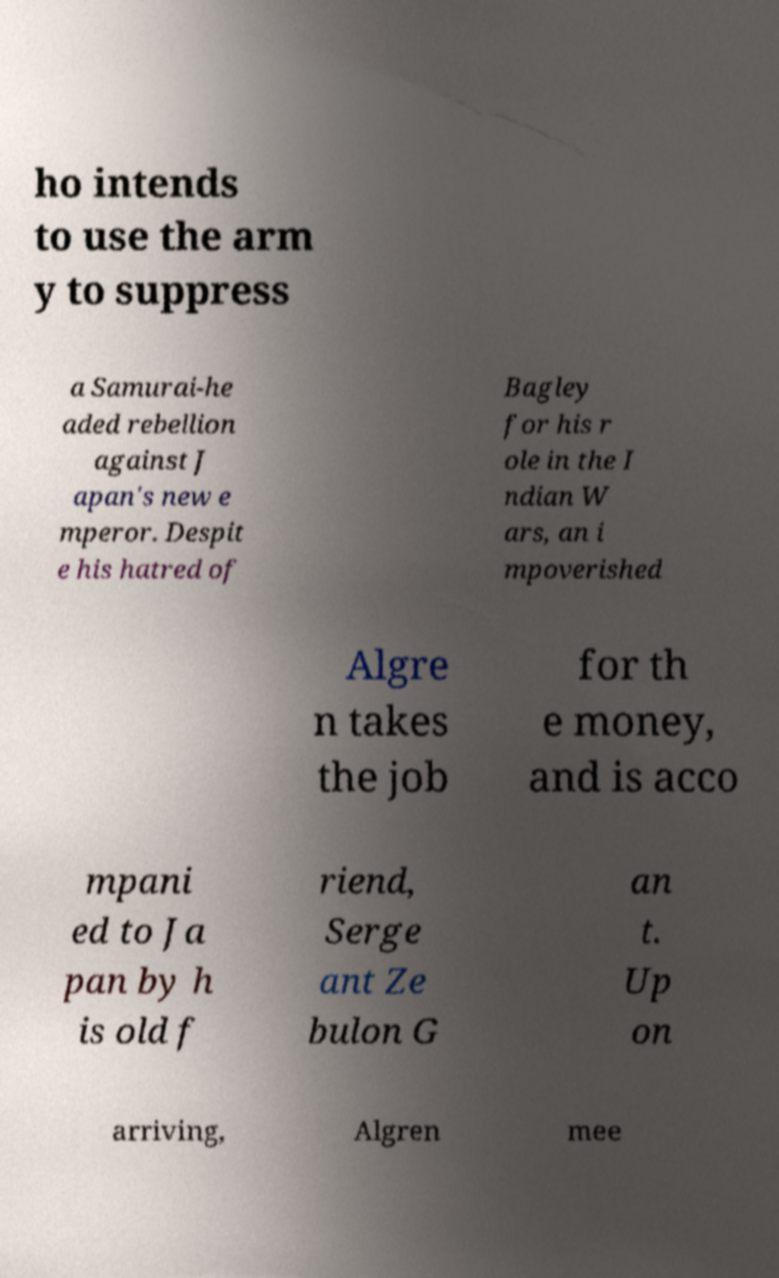There's text embedded in this image that I need extracted. Can you transcribe it verbatim? ho intends to use the arm y to suppress a Samurai-he aded rebellion against J apan's new e mperor. Despit e his hatred of Bagley for his r ole in the I ndian W ars, an i mpoverished Algre n takes the job for th e money, and is acco mpani ed to Ja pan by h is old f riend, Serge ant Ze bulon G an t. Up on arriving, Algren mee 